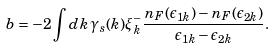<formula> <loc_0><loc_0><loc_500><loc_500>b = - 2 \int d { k } \, \gamma _ { s } ( { k } ) \xi _ { k } ^ { - } \frac { n _ { F } ( \epsilon _ { 1 { k } } ) - n _ { F } ( \epsilon _ { 2 { k } } ) } { \epsilon _ { 1 { k } } - \epsilon _ { 2 { k } } } .</formula> 